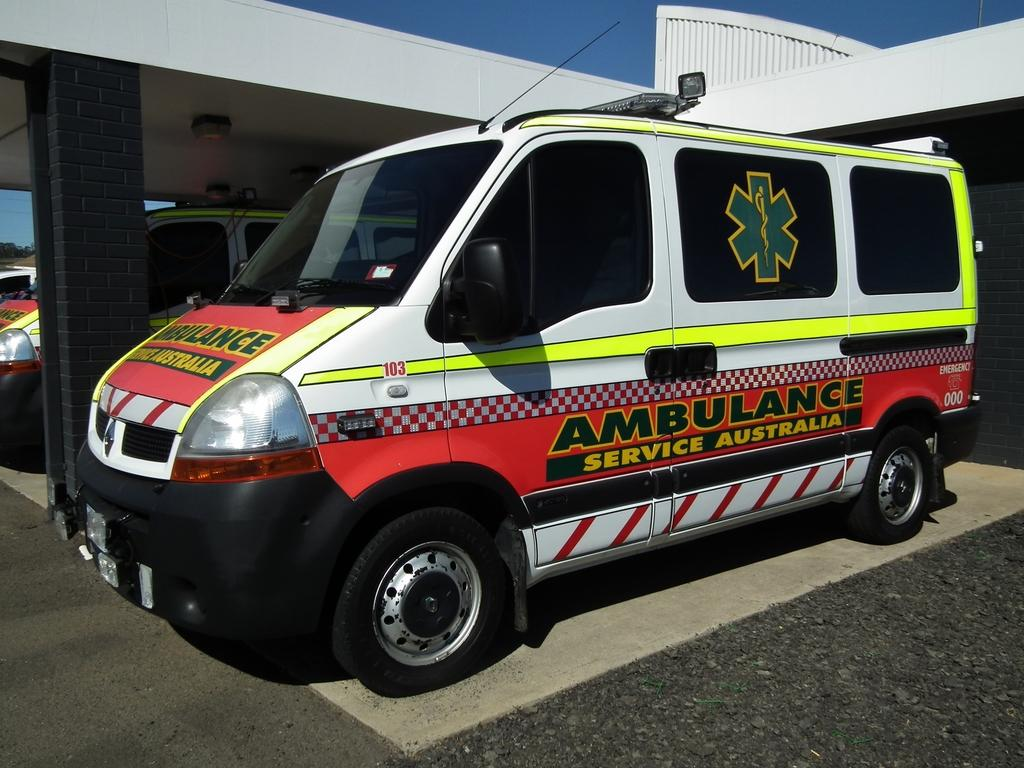<image>
Offer a succinct explanation of the picture presented. White and red ambulance which says "Service Australia". 